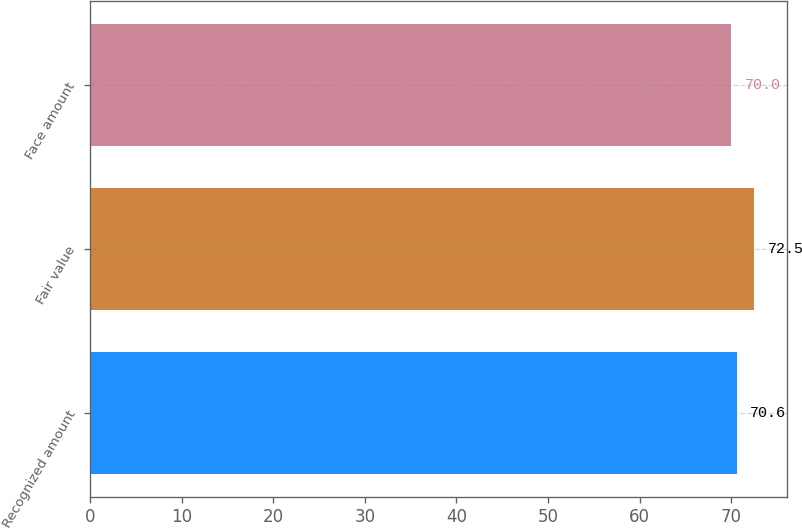Convert chart to OTSL. <chart><loc_0><loc_0><loc_500><loc_500><bar_chart><fcel>Recognized amount<fcel>Fair value<fcel>Face amount<nl><fcel>70.6<fcel>72.5<fcel>70<nl></chart> 